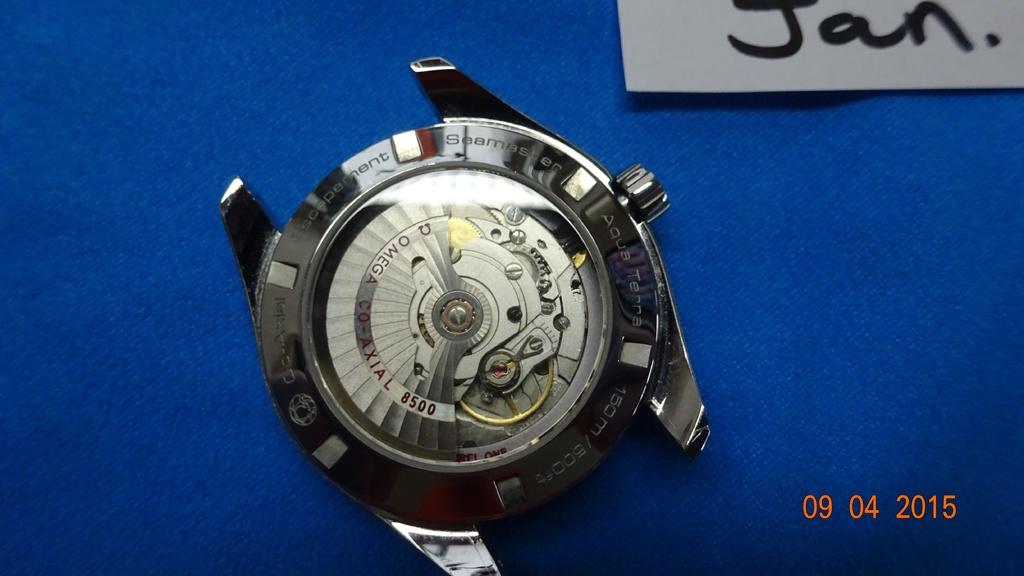What year was this picture taken?
Give a very brief answer. 2015. What kind of watch is that?
Ensure brevity in your answer.  Seamaster. 